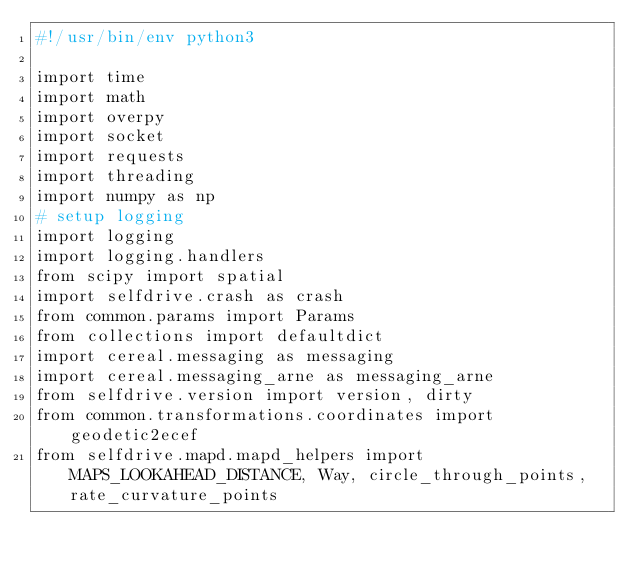<code> <loc_0><loc_0><loc_500><loc_500><_Python_>#!/usr/bin/env python3

import time
import math
import overpy
import socket
import requests
import threading
import numpy as np
# setup logging
import logging
import logging.handlers
from scipy import spatial
import selfdrive.crash as crash
from common.params import Params
from collections import defaultdict
import cereal.messaging as messaging
import cereal.messaging_arne as messaging_arne
from selfdrive.version import version, dirty
from common.transformations.coordinates import geodetic2ecef
from selfdrive.mapd.mapd_helpers import MAPS_LOOKAHEAD_DISTANCE, Way, circle_through_points, rate_curvature_points
</code> 